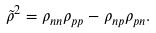<formula> <loc_0><loc_0><loc_500><loc_500>\tilde { \rho } ^ { 2 } = \rho _ { n n } \rho _ { p p } - \rho _ { n p } \rho _ { p n } .</formula> 